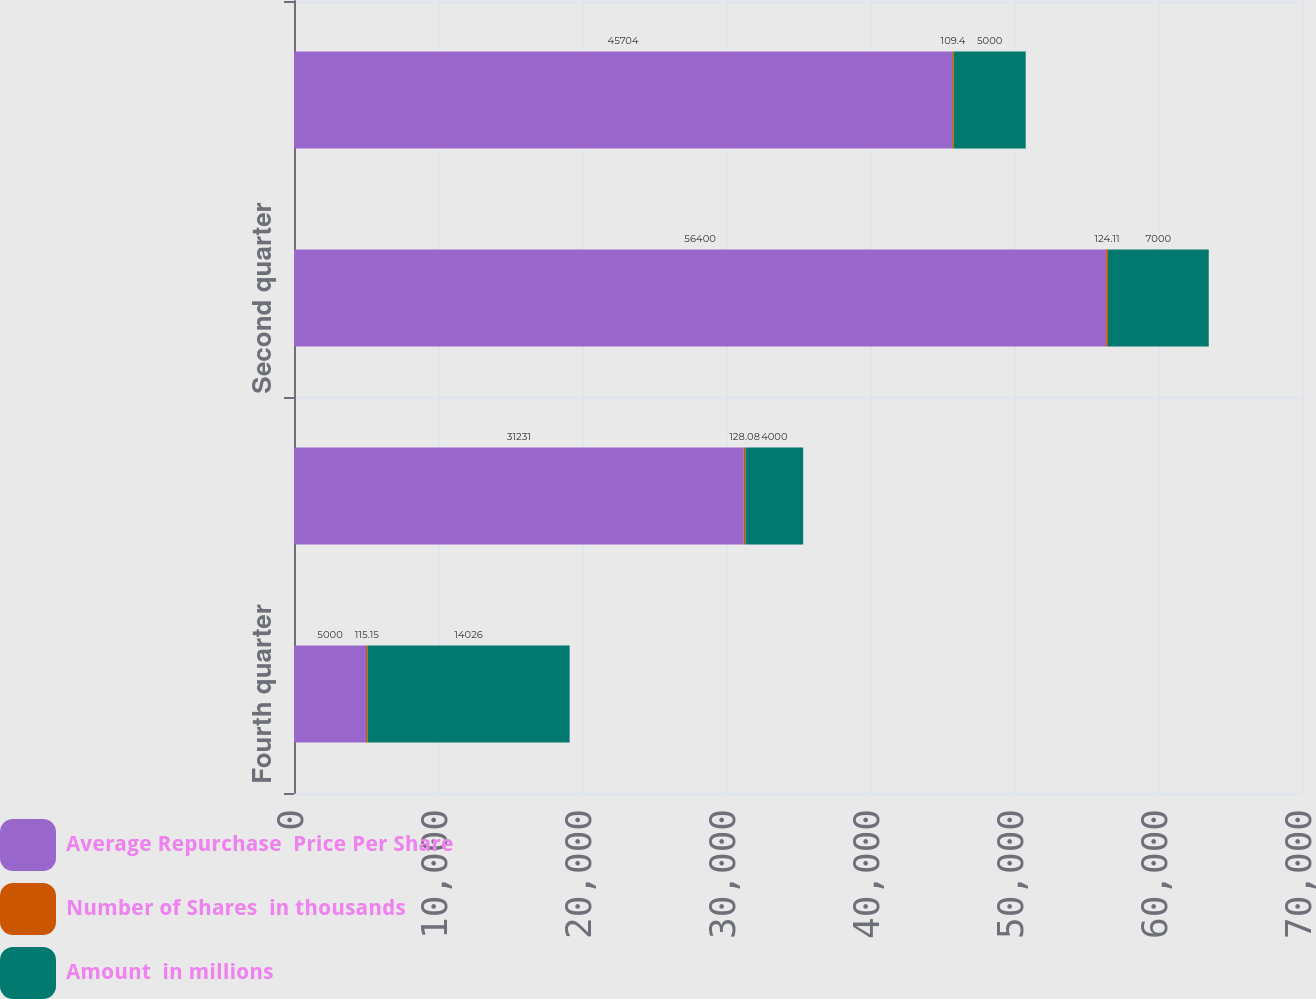<chart> <loc_0><loc_0><loc_500><loc_500><stacked_bar_chart><ecel><fcel>Fourth quarter<fcel>Third quarter<fcel>Second quarter<fcel>First quarter<nl><fcel>Average Repurchase  Price Per Share<fcel>5000<fcel>31231<fcel>56400<fcel>45704<nl><fcel>Number of Shares  in thousands<fcel>115.15<fcel>128.08<fcel>124.11<fcel>109.4<nl><fcel>Amount  in millions<fcel>14026<fcel>4000<fcel>7000<fcel>5000<nl></chart> 